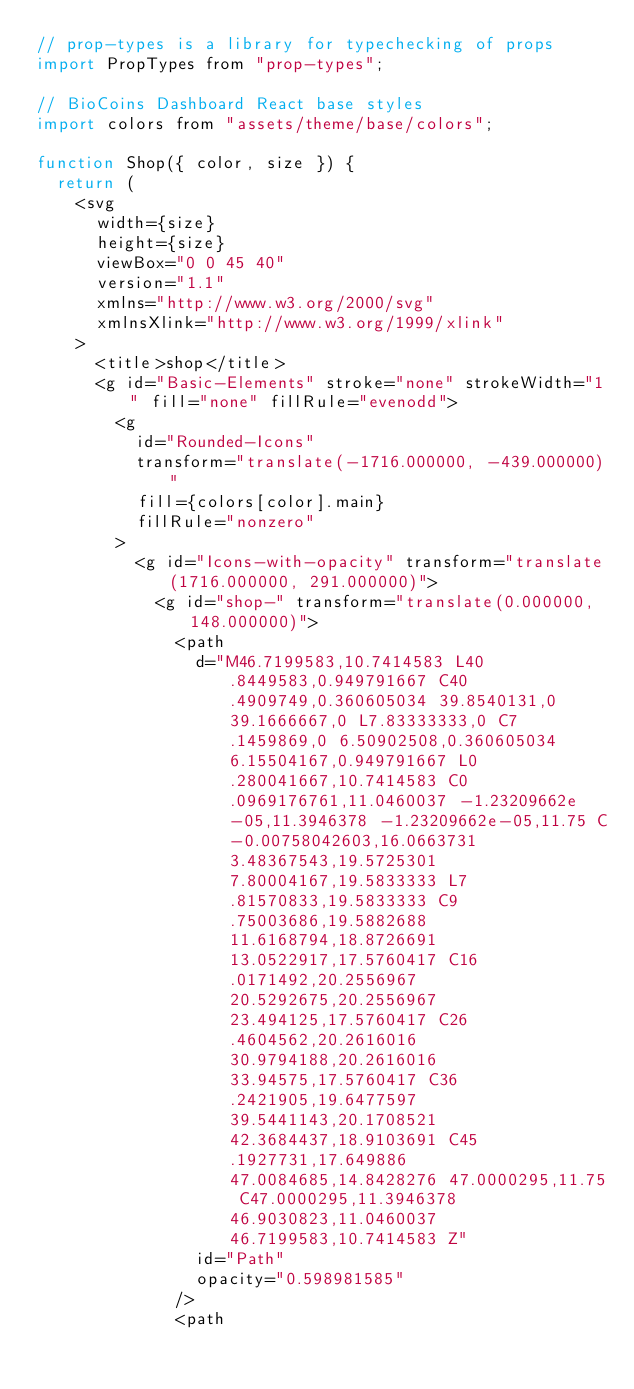<code> <loc_0><loc_0><loc_500><loc_500><_JavaScript_>// prop-types is a library for typechecking of props
import PropTypes from "prop-types";

// BioCoins Dashboard React base styles
import colors from "assets/theme/base/colors";

function Shop({ color, size }) {
  return (
    <svg
      width={size}
      height={size}
      viewBox="0 0 45 40"
      version="1.1"
      xmlns="http://www.w3.org/2000/svg"
      xmlnsXlink="http://www.w3.org/1999/xlink"
    >
      <title>shop</title>
      <g id="Basic-Elements" stroke="none" strokeWidth="1" fill="none" fillRule="evenodd">
        <g
          id="Rounded-Icons"
          transform="translate(-1716.000000, -439.000000)"
          fill={colors[color].main}
          fillRule="nonzero"
        >
          <g id="Icons-with-opacity" transform="translate(1716.000000, 291.000000)">
            <g id="shop-" transform="translate(0.000000, 148.000000)">
              <path
                d="M46.7199583,10.7414583 L40.8449583,0.949791667 C40.4909749,0.360605034 39.8540131,0 39.1666667,0 L7.83333333,0 C7.1459869,0 6.50902508,0.360605034 6.15504167,0.949791667 L0.280041667,10.7414583 C0.0969176761,11.0460037 -1.23209662e-05,11.3946378 -1.23209662e-05,11.75 C-0.00758042603,16.0663731 3.48367543,19.5725301 7.80004167,19.5833333 L7.81570833,19.5833333 C9.75003686,19.5882688 11.6168794,18.8726691 13.0522917,17.5760417 C16.0171492,20.2556967 20.5292675,20.2556967 23.494125,17.5760417 C26.4604562,20.2616016 30.9794188,20.2616016 33.94575,17.5760417 C36.2421905,19.6477597 39.5441143,20.1708521 42.3684437,18.9103691 C45.1927731,17.649886 47.0084685,14.8428276 47.0000295,11.75 C47.0000295,11.3946378 46.9030823,11.0460037 46.7199583,10.7414583 Z"
                id="Path"
                opacity="0.598981585"
              />
              <path</code> 